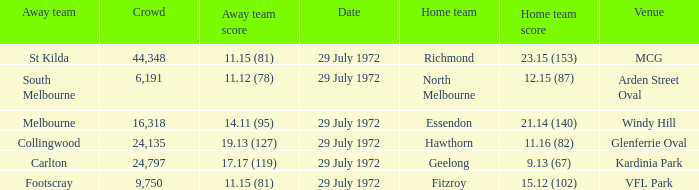What was the largest crowd size at arden street oval? 6191.0. 